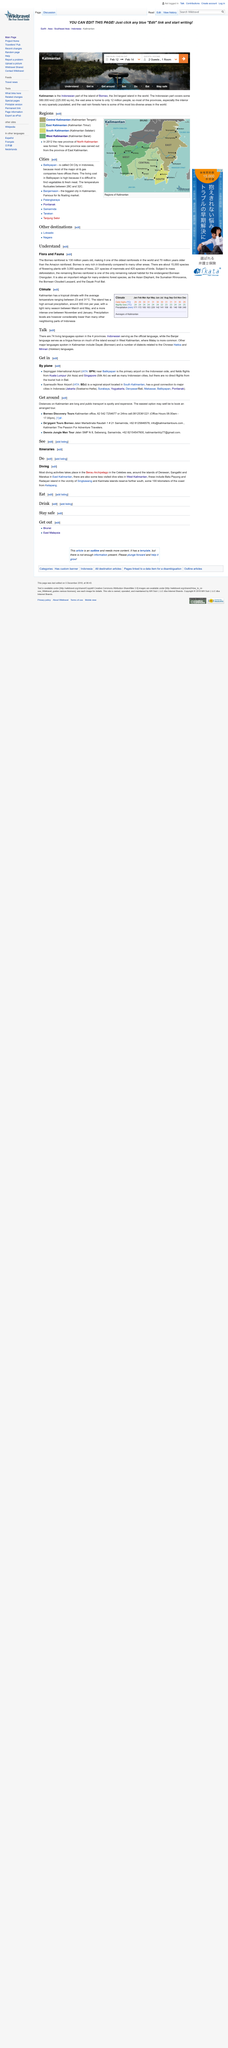Outline some significant characteristics in this image. There are 74 living languages spoken in Indonesia. The official language of Kalimantan is Indonesian. Kalimantan has a tropical climate characterized by high temperatures and high humidity throughout the year. 